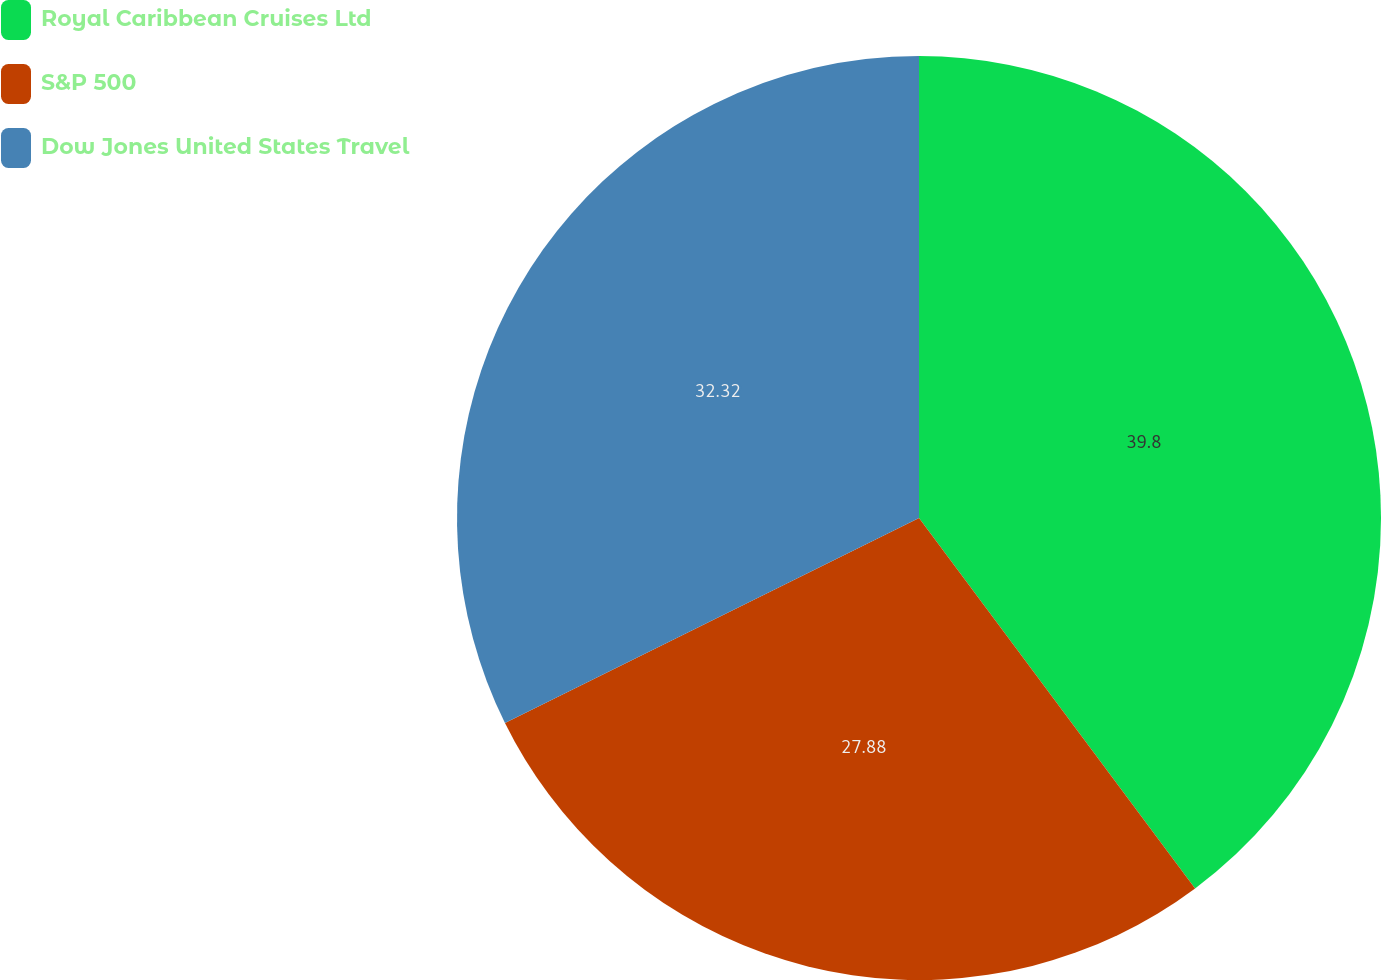<chart> <loc_0><loc_0><loc_500><loc_500><pie_chart><fcel>Royal Caribbean Cruises Ltd<fcel>S&P 500<fcel>Dow Jones United States Travel<nl><fcel>39.81%<fcel>27.88%<fcel>32.32%<nl></chart> 